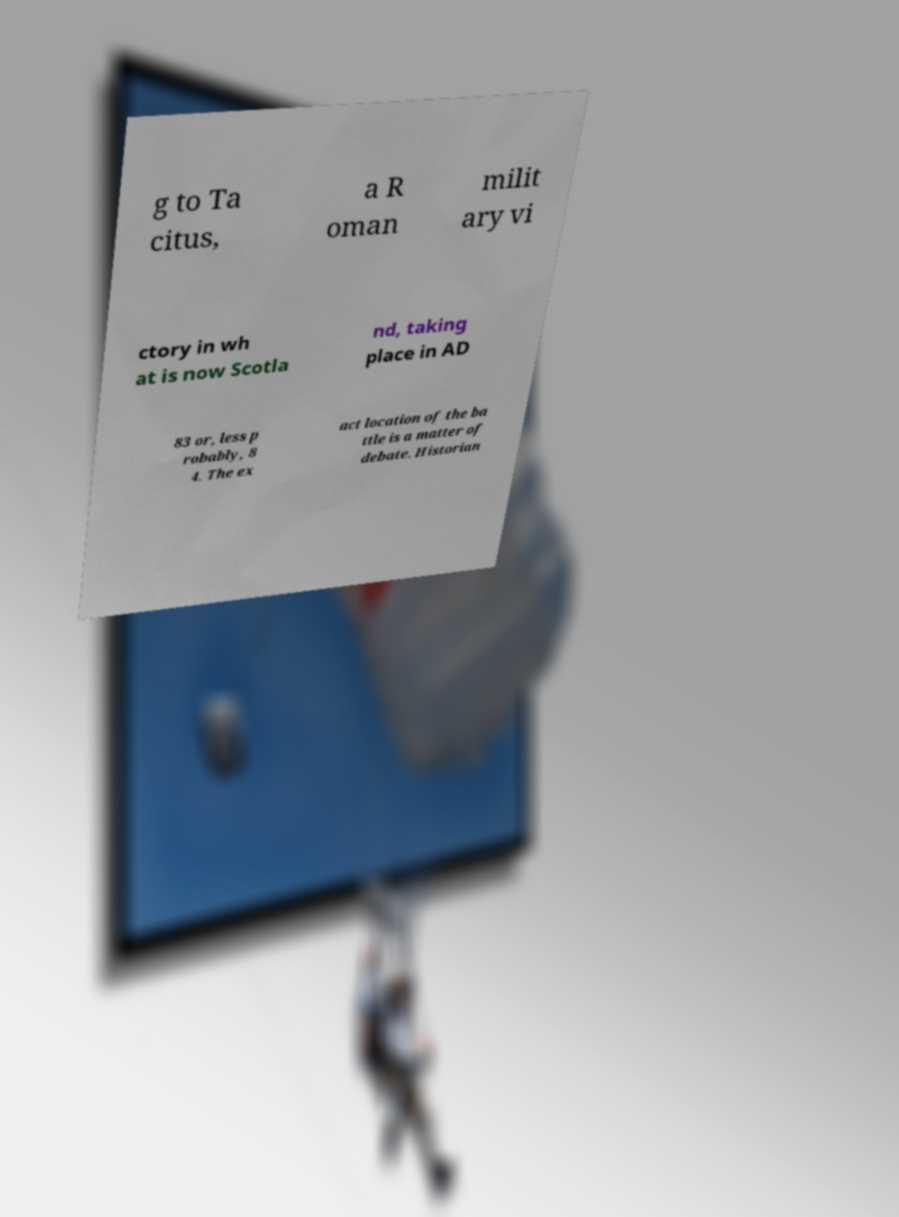Could you extract and type out the text from this image? g to Ta citus, a R oman milit ary vi ctory in wh at is now Scotla nd, taking place in AD 83 or, less p robably, 8 4. The ex act location of the ba ttle is a matter of debate. Historian 